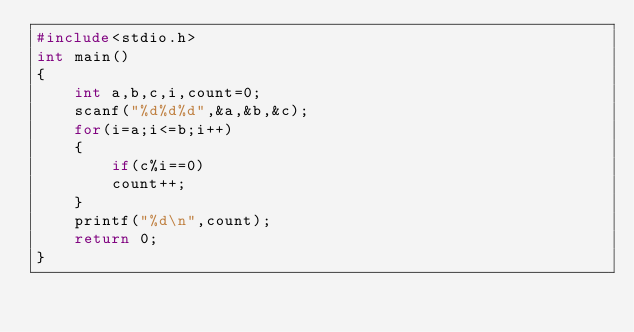<code> <loc_0><loc_0><loc_500><loc_500><_C_>#include<stdio.h>
int main()
{
    int a,b,c,i,count=0;
    scanf("%d%d%d",&a,&b,&c);
    for(i=a;i<=b;i++)
    {
        if(c%i==0)
        count++;
    }
    printf("%d\n",count);
    return 0;
}
</code> 